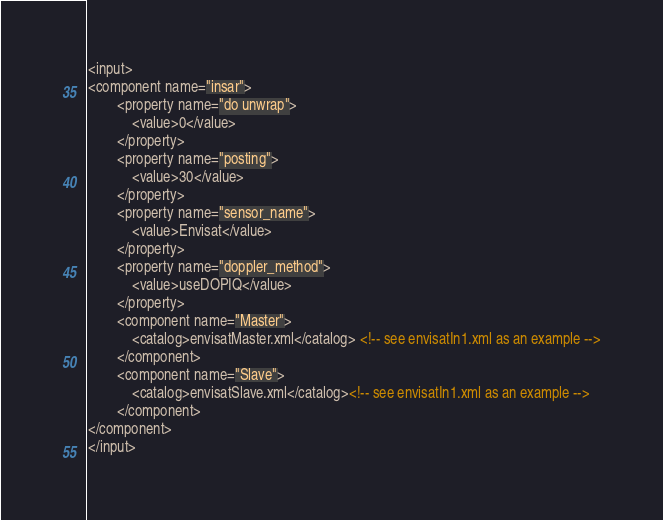<code> <loc_0><loc_0><loc_500><loc_500><_XML_><input>
<component name="insar">
        <property name="do unwrap">
            <value>0</value>
        </property>
        <property name="posting">
            <value>30</value>
        </property>
        <property name="sensor_name">
            <value>Envisat</value>
        </property>
        <property name="doppler_method">
            <value>useDOPIQ</value>
        </property>
        <component name="Master">
            <catalog>envisatMaster.xml</catalog> <!-- see envisatIn1.xml as an example -->
        </component>
        <component name="Slave">
            <catalog>envisatSlave.xml</catalog><!-- see envisatIn1.xml as an example -->
        </component>
</component>
</input>
</code> 